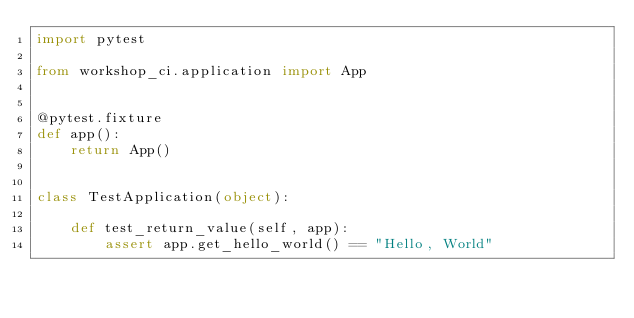<code> <loc_0><loc_0><loc_500><loc_500><_Python_>import pytest

from workshop_ci.application import App


@pytest.fixture
def app():
    return App()


class TestApplication(object):

    def test_return_value(self, app):
        assert app.get_hello_world() == "Hello, World"
</code> 